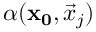<formula> <loc_0><loc_0><loc_500><loc_500>\alpha ( x _ { 0 } , \vec { x } _ { j } )</formula> 